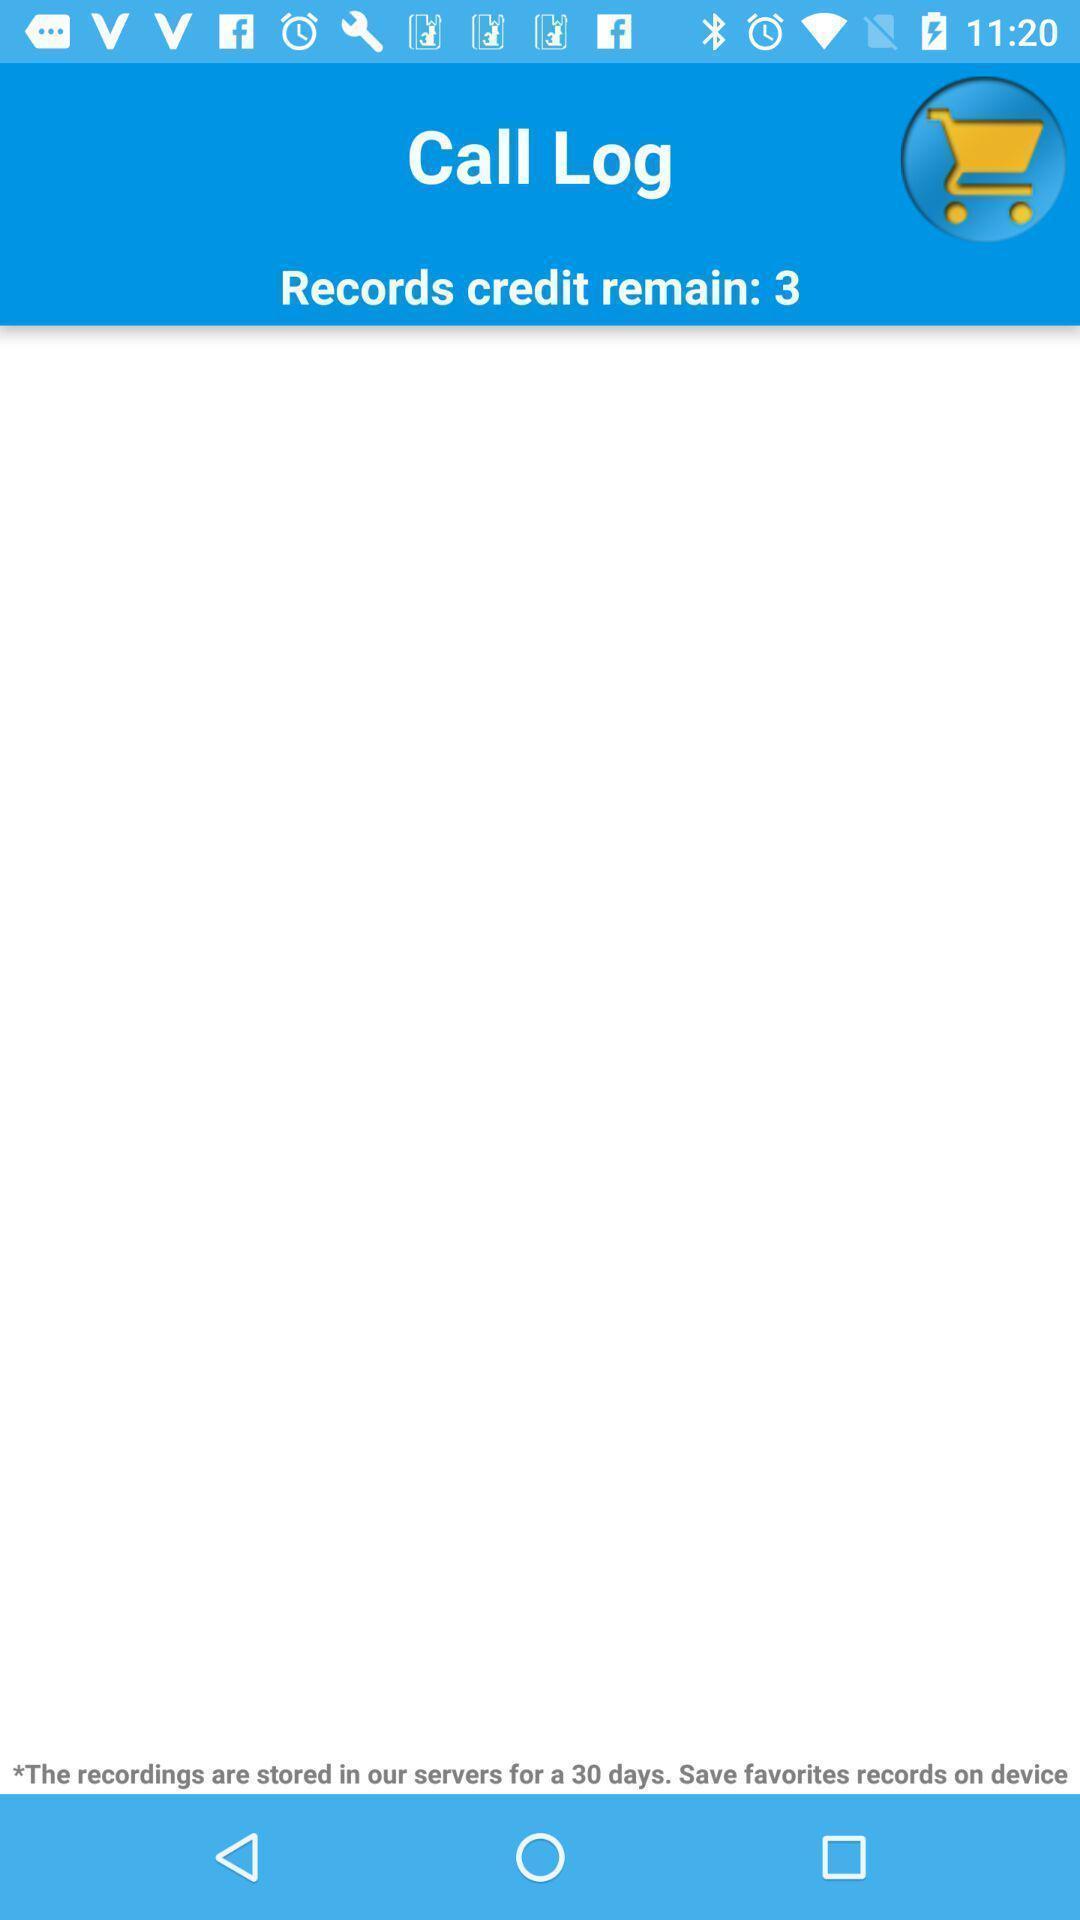What details can you identify in this image? Screen showing records credits remain:3. 